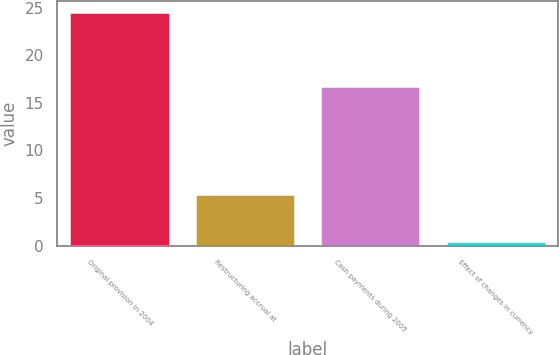<chart> <loc_0><loc_0><loc_500><loc_500><bar_chart><fcel>Original provision in 2004<fcel>Restructuring accrual at<fcel>Cash payments during 2005<fcel>Effect of changes in currency<nl><fcel>24.52<fcel>5.4<fcel>16.8<fcel>0.5<nl></chart> 